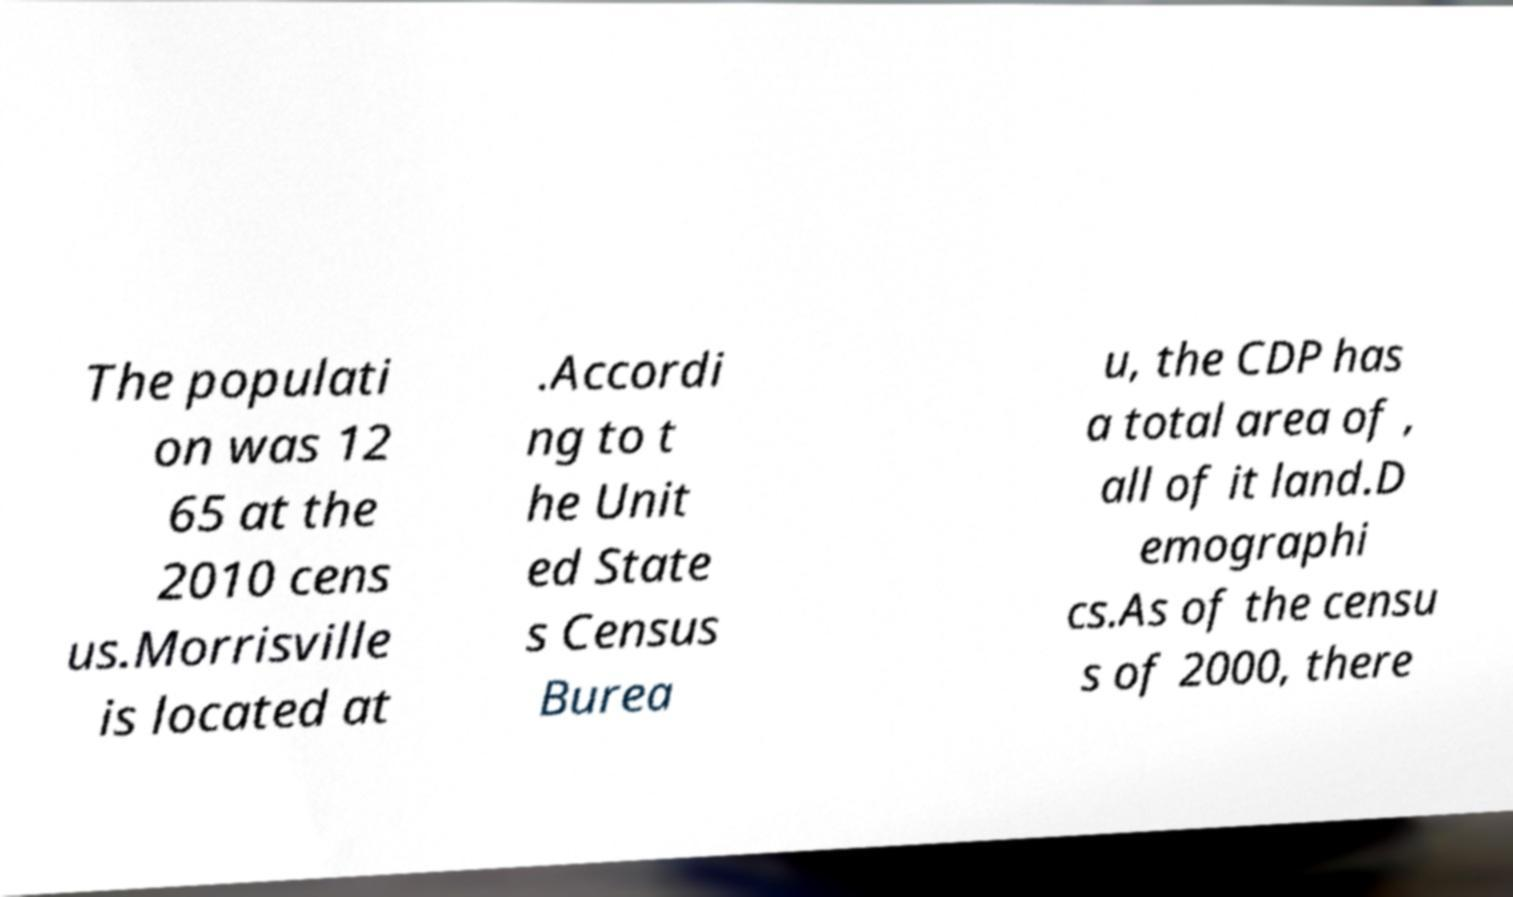Please read and relay the text visible in this image. What does it say? The populati on was 12 65 at the 2010 cens us.Morrisville is located at .Accordi ng to t he Unit ed State s Census Burea u, the CDP has a total area of , all of it land.D emographi cs.As of the censu s of 2000, there 